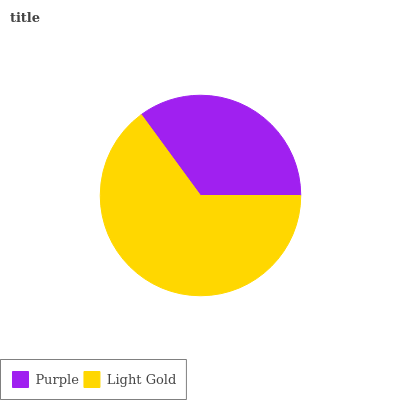Is Purple the minimum?
Answer yes or no. Yes. Is Light Gold the maximum?
Answer yes or no. Yes. Is Light Gold the minimum?
Answer yes or no. No. Is Light Gold greater than Purple?
Answer yes or no. Yes. Is Purple less than Light Gold?
Answer yes or no. Yes. Is Purple greater than Light Gold?
Answer yes or no. No. Is Light Gold less than Purple?
Answer yes or no. No. Is Light Gold the high median?
Answer yes or no. Yes. Is Purple the low median?
Answer yes or no. Yes. Is Purple the high median?
Answer yes or no. No. Is Light Gold the low median?
Answer yes or no. No. 